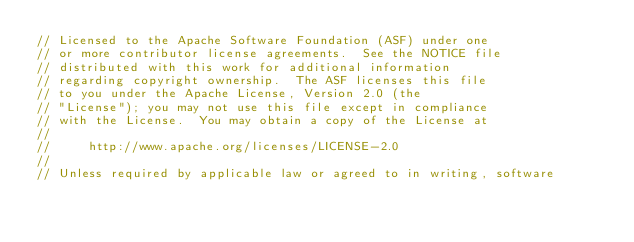<code> <loc_0><loc_0><loc_500><loc_500><_C++_>// Licensed to the Apache Software Foundation (ASF) under one
// or more contributor license agreements.  See the NOTICE file
// distributed with this work for additional information
// regarding copyright ownership.  The ASF licenses this file
// to you under the Apache License, Version 2.0 (the
// "License"); you may not use this file except in compliance
// with the License.  You may obtain a copy of the License at
//
//     http://www.apache.org/licenses/LICENSE-2.0
//
// Unless required by applicable law or agreed to in writing, software</code> 